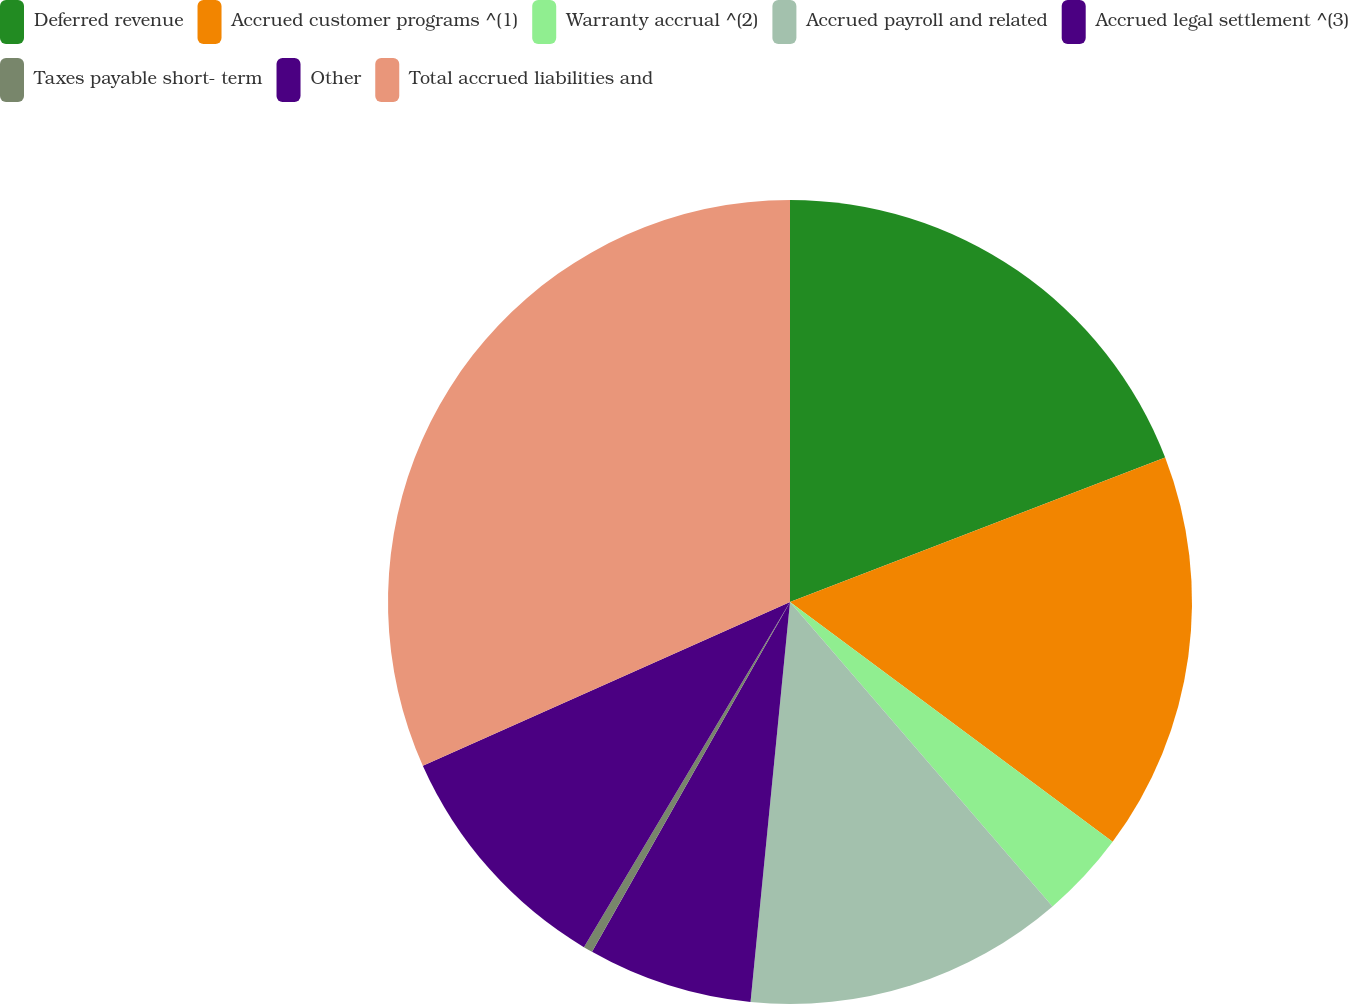Convert chart. <chart><loc_0><loc_0><loc_500><loc_500><pie_chart><fcel>Deferred revenue<fcel>Accrued customer programs ^(1)<fcel>Warranty accrual ^(2)<fcel>Accrued payroll and related<fcel>Accrued legal settlement ^(3)<fcel>Taxes payable short- term<fcel>Other<fcel>Total accrued liabilities and<nl><fcel>19.15%<fcel>16.02%<fcel>3.5%<fcel>12.89%<fcel>6.63%<fcel>0.37%<fcel>9.76%<fcel>31.67%<nl></chart> 